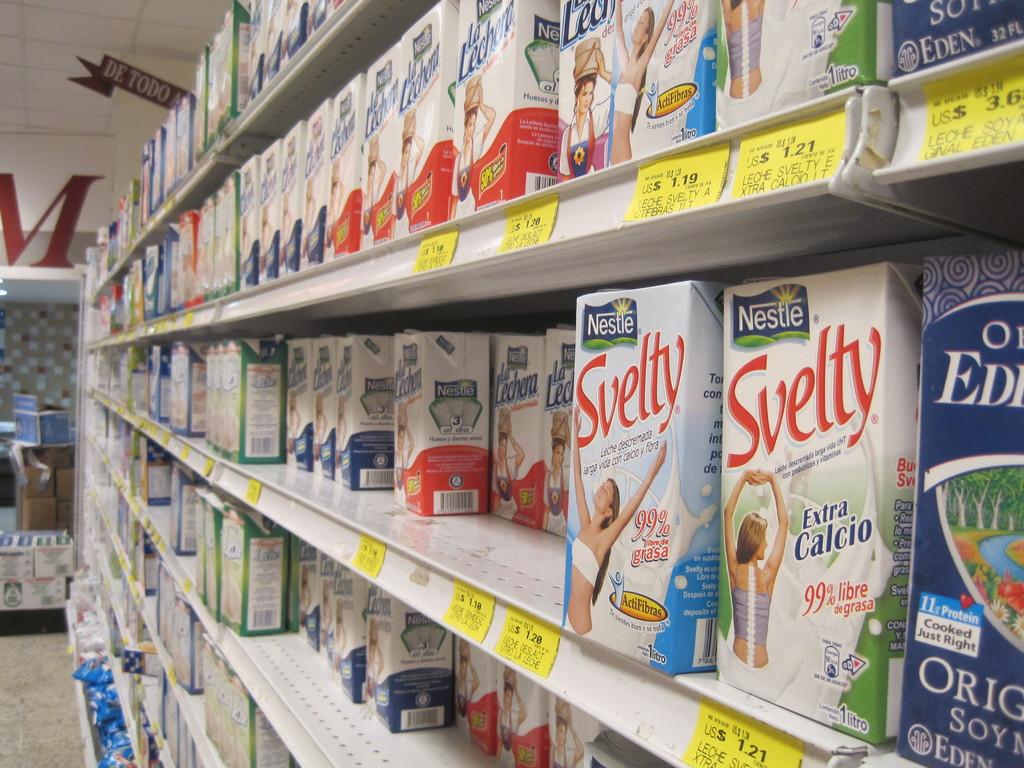What does svelty have extra of?
Keep it short and to the point. Calcio. 